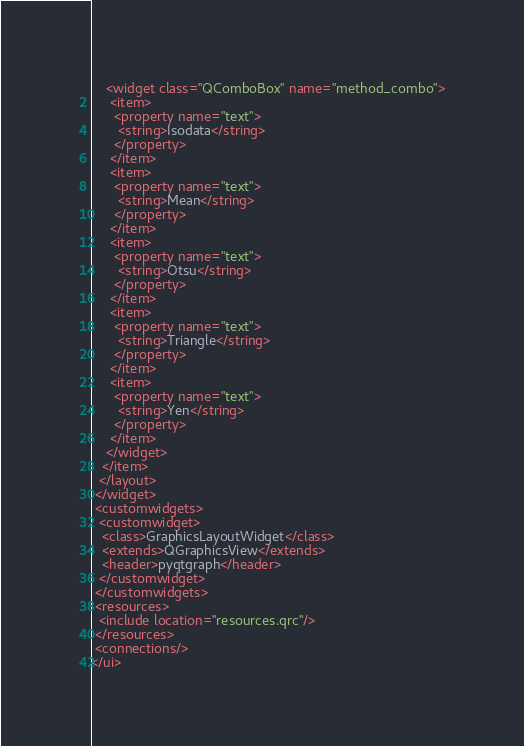Convert code to text. <code><loc_0><loc_0><loc_500><loc_500><_XML_>    <widget class="QComboBox" name="method_combo">
     <item>
      <property name="text">
       <string>Isodata</string>
      </property>
     </item>
     <item>
      <property name="text">
       <string>Mean</string>
      </property>
     </item>
     <item>
      <property name="text">
       <string>Otsu</string>
      </property>
     </item>
     <item>
      <property name="text">
       <string>Triangle</string>
      </property>
     </item>
     <item>
      <property name="text">
       <string>Yen</string>
      </property>
     </item>
    </widget>
   </item>
  </layout>
 </widget>
 <customwidgets>
  <customwidget>
   <class>GraphicsLayoutWidget</class>
   <extends>QGraphicsView</extends>
   <header>pyqtgraph</header>
  </customwidget>
 </customwidgets>
 <resources>
  <include location="resources.qrc"/>
 </resources>
 <connections/>
</ui>
</code> 